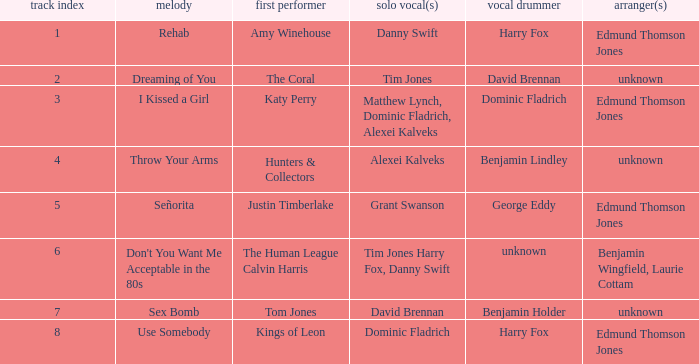Who is the arranger for "I KIssed a Girl"? Edmund Thomson Jones. 